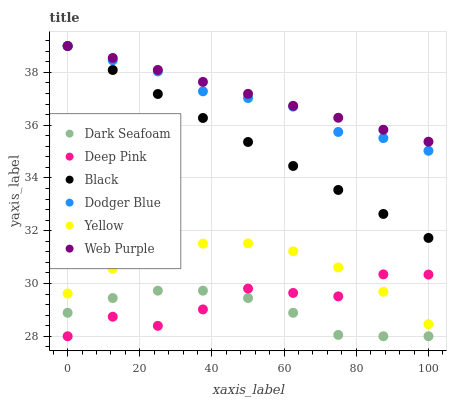Does Dark Seafoam have the minimum area under the curve?
Answer yes or no. Yes. Does Web Purple have the maximum area under the curve?
Answer yes or no. Yes. Does Yellow have the minimum area under the curve?
Answer yes or no. No. Does Yellow have the maximum area under the curve?
Answer yes or no. No. Is Black the smoothest?
Answer yes or no. Yes. Is Deep Pink the roughest?
Answer yes or no. Yes. Is Web Purple the smoothest?
Answer yes or no. No. Is Web Purple the roughest?
Answer yes or no. No. Does Deep Pink have the lowest value?
Answer yes or no. Yes. Does Yellow have the lowest value?
Answer yes or no. No. Does Black have the highest value?
Answer yes or no. Yes. Does Yellow have the highest value?
Answer yes or no. No. Is Deep Pink less than Dodger Blue?
Answer yes or no. Yes. Is Dodger Blue greater than Dark Seafoam?
Answer yes or no. Yes. Does Dodger Blue intersect Black?
Answer yes or no. Yes. Is Dodger Blue less than Black?
Answer yes or no. No. Is Dodger Blue greater than Black?
Answer yes or no. No. Does Deep Pink intersect Dodger Blue?
Answer yes or no. No. 